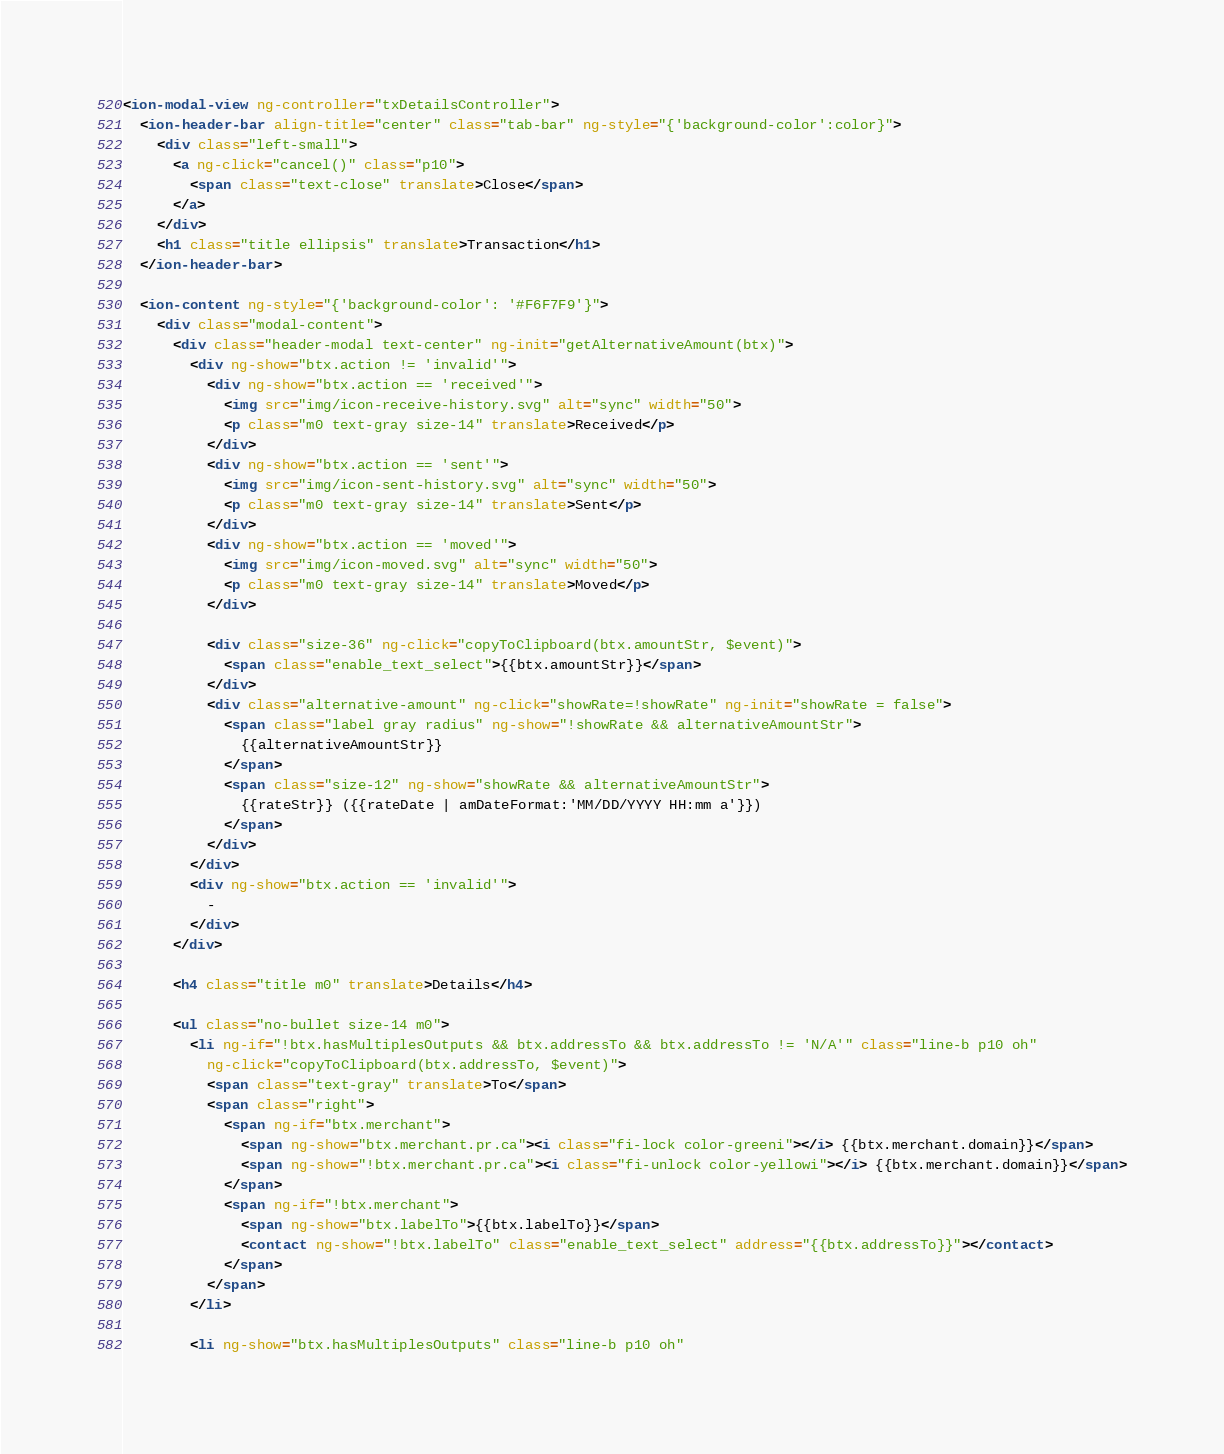<code> <loc_0><loc_0><loc_500><loc_500><_HTML_><ion-modal-view ng-controller="txDetailsController">
  <ion-header-bar align-title="center" class="tab-bar" ng-style="{'background-color':color}">
    <div class="left-small">
      <a ng-click="cancel()" class="p10">
        <span class="text-close" translate>Close</span>
      </a>
    </div>
    <h1 class="title ellipsis" translate>Transaction</h1>
  </ion-header-bar>

  <ion-content ng-style="{'background-color': '#F6F7F9'}">
    <div class="modal-content">
      <div class="header-modal text-center" ng-init="getAlternativeAmount(btx)">
        <div ng-show="btx.action != 'invalid'">
          <div ng-show="btx.action == 'received'">
            <img src="img/icon-receive-history.svg" alt="sync" width="50">
            <p class="m0 text-gray size-14" translate>Received</p>
          </div>
          <div ng-show="btx.action == 'sent'">
            <img src="img/icon-sent-history.svg" alt="sync" width="50">
            <p class="m0 text-gray size-14" translate>Sent</p>
          </div>
          <div ng-show="btx.action == 'moved'">
            <img src="img/icon-moved.svg" alt="sync" width="50">
            <p class="m0 text-gray size-14" translate>Moved</p>
          </div>

          <div class="size-36" ng-click="copyToClipboard(btx.amountStr, $event)">
            <span class="enable_text_select">{{btx.amountStr}}</span>
          </div>
          <div class="alternative-amount" ng-click="showRate=!showRate" ng-init="showRate = false">
            <span class="label gray radius" ng-show="!showRate && alternativeAmountStr">
              {{alternativeAmountStr}}
            </span>
            <span class="size-12" ng-show="showRate && alternativeAmountStr">
              {{rateStr}} ({{rateDate | amDateFormat:'MM/DD/YYYY HH:mm a'}})
            </span>
          </div>
        </div>
        <div ng-show="btx.action == 'invalid'">
          -
        </div>
      </div>

      <h4 class="title m0" translate>Details</h4>

      <ul class="no-bullet size-14 m0">
        <li ng-if="!btx.hasMultiplesOutputs && btx.addressTo && btx.addressTo != 'N/A'" class="line-b p10 oh"
          ng-click="copyToClipboard(btx.addressTo, $event)">
          <span class="text-gray" translate>To</span>
          <span class="right">
            <span ng-if="btx.merchant">
              <span ng-show="btx.merchant.pr.ca"><i class="fi-lock color-greeni"></i> {{btx.merchant.domain}}</span>
              <span ng-show="!btx.merchant.pr.ca"><i class="fi-unlock color-yellowi"></i> {{btx.merchant.domain}}</span>
            </span>
            <span ng-if="!btx.merchant">
              <span ng-show="btx.labelTo">{{btx.labelTo}}</span>
              <contact ng-show="!btx.labelTo" class="enable_text_select" address="{{btx.addressTo}}"></contact>
            </span>
          </span>
        </li>

        <li ng-show="btx.hasMultiplesOutputs" class="line-b p10 oh"</code> 